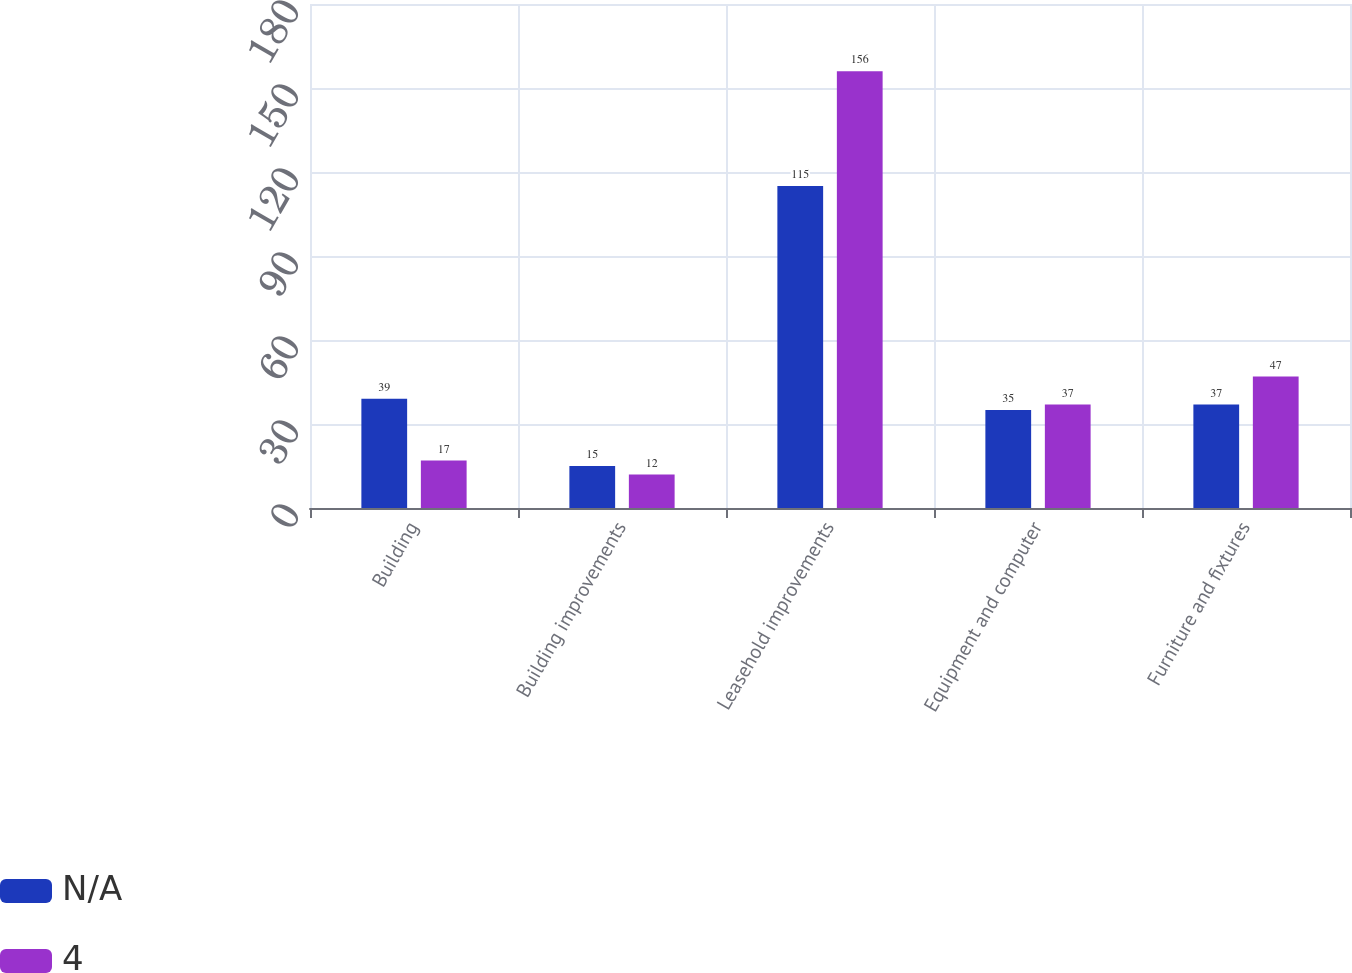Convert chart to OTSL. <chart><loc_0><loc_0><loc_500><loc_500><stacked_bar_chart><ecel><fcel>Building<fcel>Building improvements<fcel>Leasehold improvements<fcel>Equipment and computer<fcel>Furniture and fixtures<nl><fcel>nan<fcel>39<fcel>15<fcel>115<fcel>35<fcel>37<nl><fcel>4<fcel>17<fcel>12<fcel>156<fcel>37<fcel>47<nl></chart> 